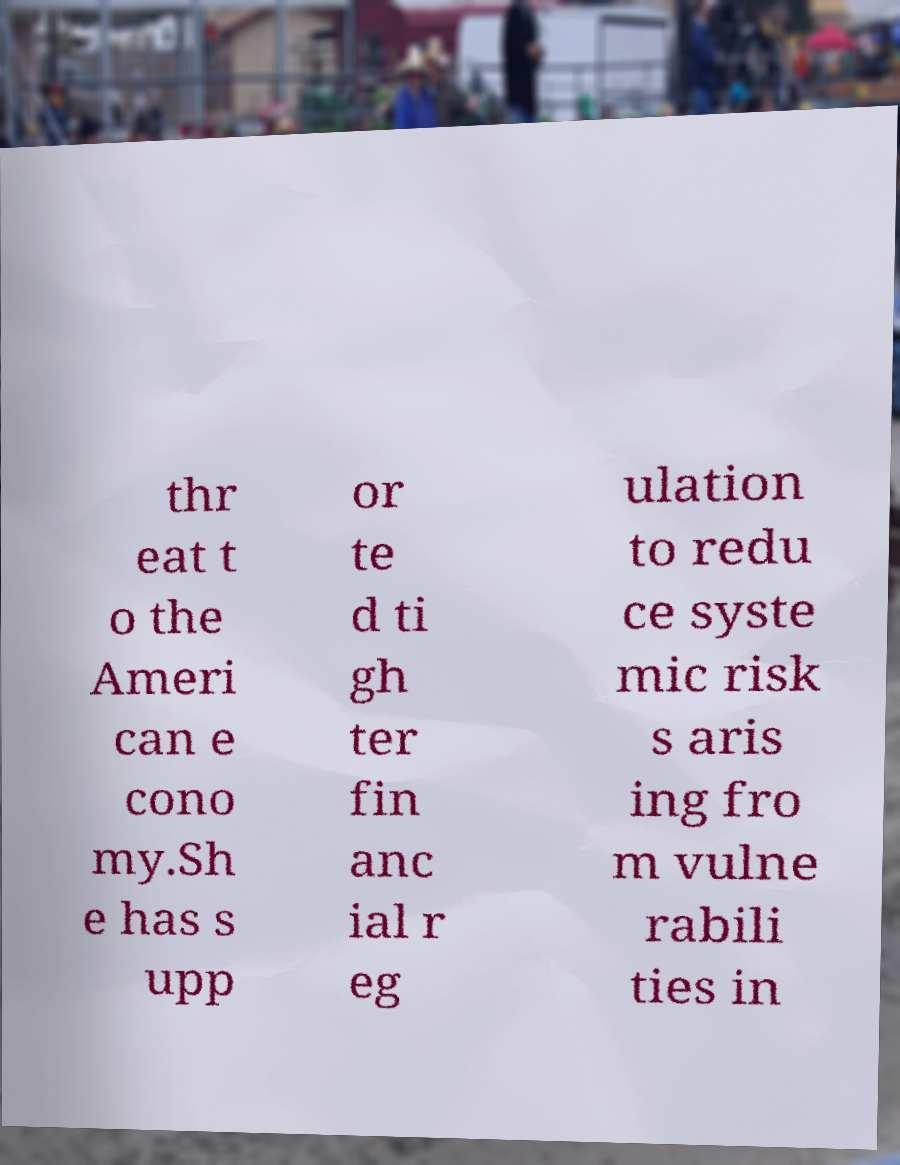Could you assist in decoding the text presented in this image and type it out clearly? thr eat t o the Ameri can e cono my.Sh e has s upp or te d ti gh ter fin anc ial r eg ulation to redu ce syste mic risk s aris ing fro m vulne rabili ties in 